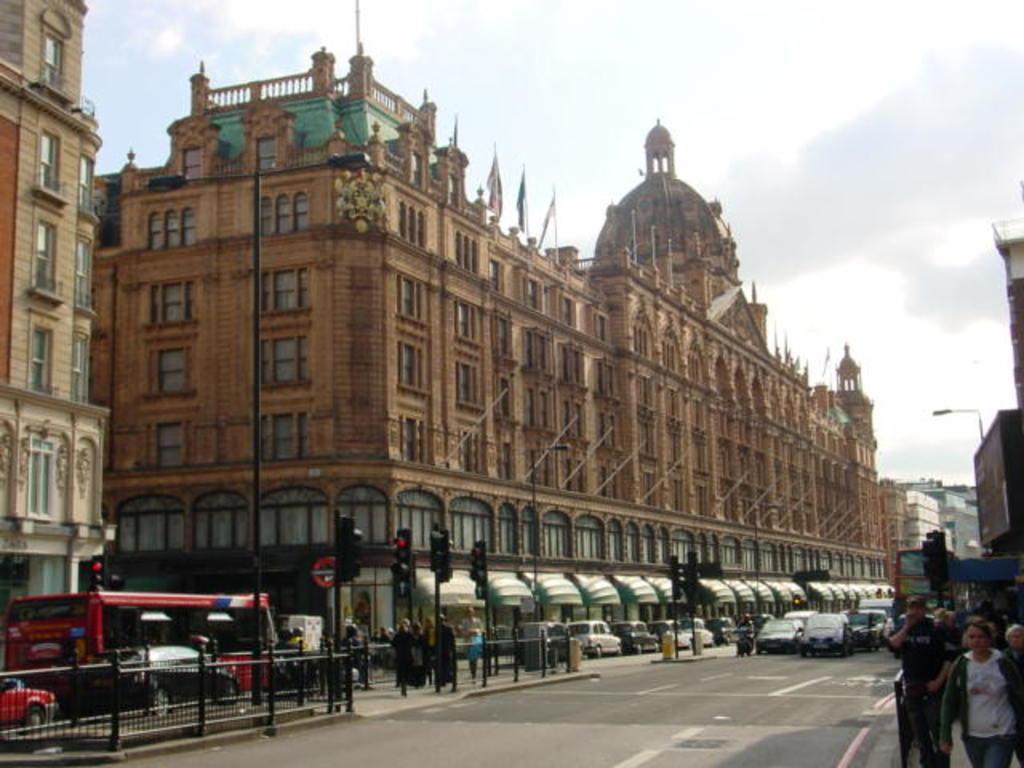Please provide a concise description of this image. In this picture I can see some vehicles on the road, some people are walking beside the fencing and I can see signal lights in the middle of the road, around I can see some buildings and poles. 